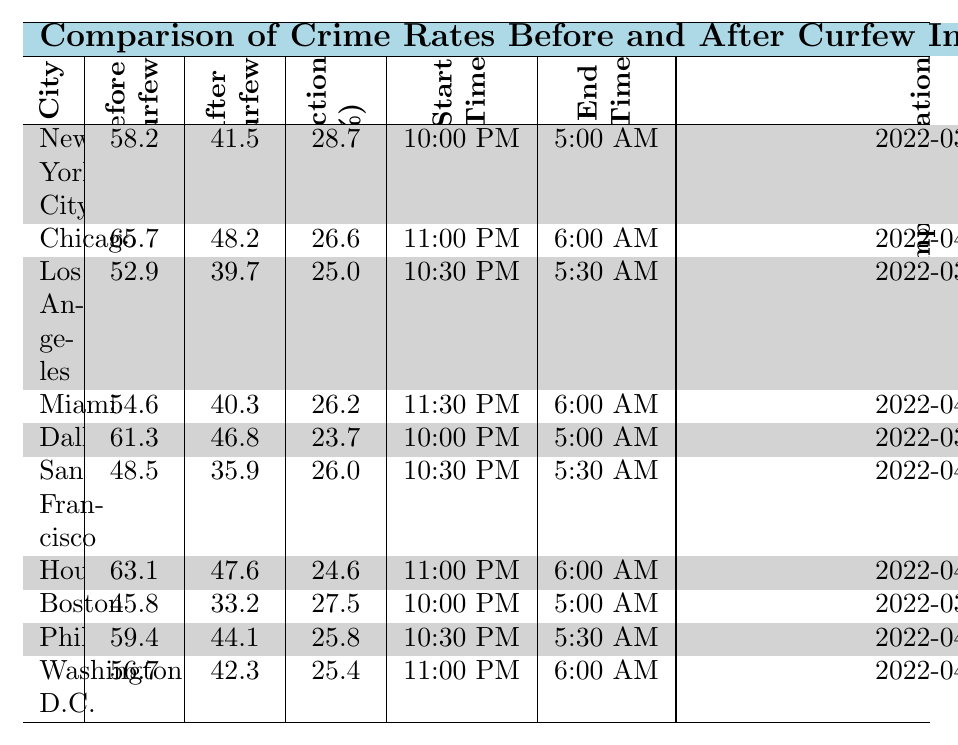What is the crime rate in New York City before the curfew? The table shows the crime rate in New York City before the curfew as 58.2.
Answer: 58.2 What is the percentage reduction in crime rate for Houston? The table indicates that Houston has a percentage reduction of 24.6%.
Answer: 24.6% Which city had the highest crime rate before the curfew? By comparing the 'Before Curfew' column, Chicago has the highest value at 65.7.
Answer: Chicago What is the average percentage reduction in crime rates across all cities? The percentage reductions are 28.7, 26.6, 25.0, 26.2, 23.7, 26.0, 24.6, 27.5, 25.8, and 25.4. Summing these values gives  26.425, and dividing by 10 gives an average of 26.4%.
Answer: 26.4% Did the curfew implemented in Boston result in a higher or lower percentage reduction compared to Miami? Boston had a percentage reduction of 27.5, while Miami had 26.2, indicating Boston's reduction is higher.
Answer: Higher What is the total crime rate reduction for New York City and Philadelphia combined? New York City has a reduction of 28.7 and Philadelphia has a reduction of 25.8. Adding these gives 28.7 + 25.8 = 54.5.
Answer: 54.5 Which city had the latest curfew implementation date? The implementation date for Chicago is 2022-04-01, which is the latest among the listed dates.
Answer: Chicago Is there a trend in crime rate reduction based on the start time of the curfew? By observing both the start times and the percentage reductions, it appears no clear trend emerges, making it inconclusive.
Answer: No clear trend What is the crime rate after curfew for Los Angeles? The crime rate after curfew for Los Angeles is noted as 39.7.
Answer: 39.7 Which city saw the smallest change in crime rate after curfew? Chicago had a reduction from 65.7 to 48.2, calculated as a change of 17.5, which is smaller than other cities.
Answer: Chicago How does the curfew time impact crime rates in terms of percentage reduction? Analyzing various cities starting the curfew at different times and their reductions shows mixed results without a direct correlation.
Answer: No direct correlation 